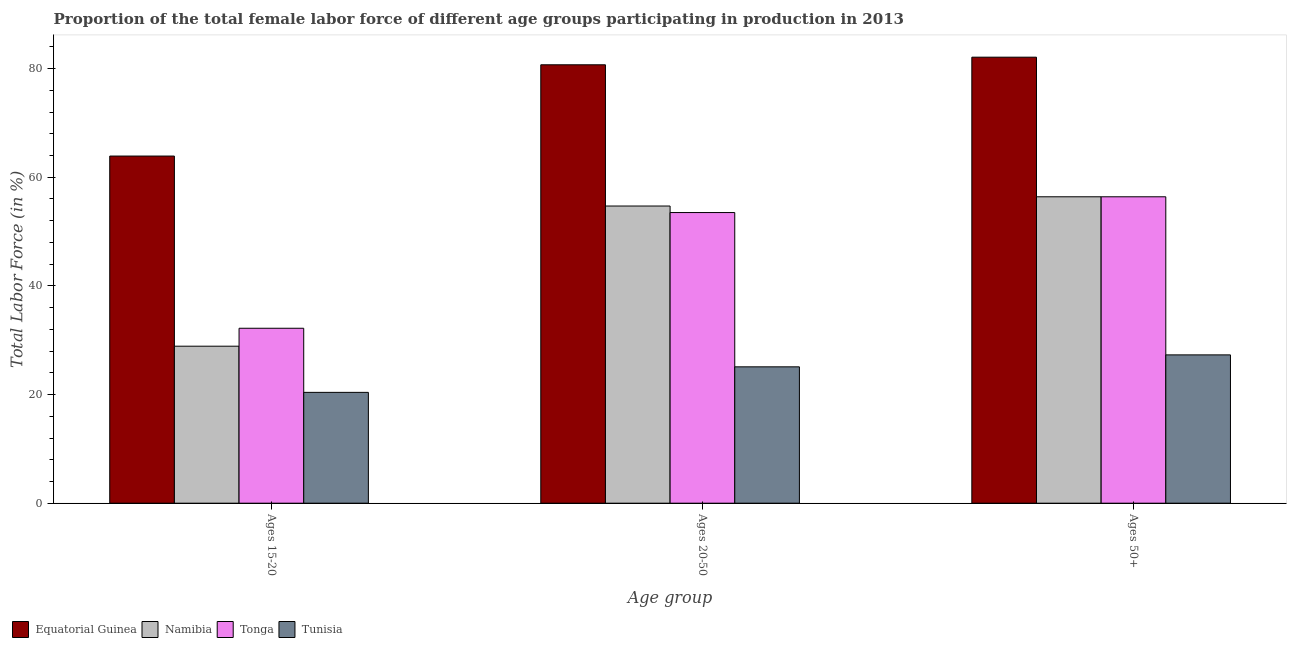How many different coloured bars are there?
Your answer should be very brief. 4. Are the number of bars per tick equal to the number of legend labels?
Make the answer very short. Yes. Are the number of bars on each tick of the X-axis equal?
Provide a succinct answer. Yes. How many bars are there on the 2nd tick from the left?
Provide a short and direct response. 4. How many bars are there on the 2nd tick from the right?
Provide a succinct answer. 4. What is the label of the 2nd group of bars from the left?
Provide a succinct answer. Ages 20-50. What is the percentage of female labor force within the age group 15-20 in Equatorial Guinea?
Give a very brief answer. 63.9. Across all countries, what is the maximum percentage of female labor force within the age group 20-50?
Provide a short and direct response. 80.7. Across all countries, what is the minimum percentage of female labor force above age 50?
Offer a terse response. 27.3. In which country was the percentage of female labor force within the age group 20-50 maximum?
Ensure brevity in your answer.  Equatorial Guinea. In which country was the percentage of female labor force within the age group 15-20 minimum?
Your response must be concise. Tunisia. What is the total percentage of female labor force within the age group 15-20 in the graph?
Your response must be concise. 145.4. What is the difference between the percentage of female labor force within the age group 15-20 in Tonga and that in Tunisia?
Provide a short and direct response. 11.8. What is the difference between the percentage of female labor force within the age group 20-50 in Equatorial Guinea and the percentage of female labor force within the age group 15-20 in Namibia?
Provide a succinct answer. 51.8. What is the average percentage of female labor force above age 50 per country?
Give a very brief answer. 55.55. What is the difference between the percentage of female labor force within the age group 20-50 and percentage of female labor force above age 50 in Namibia?
Provide a short and direct response. -1.7. What is the ratio of the percentage of female labor force above age 50 in Tunisia to that in Tonga?
Your response must be concise. 0.48. What is the difference between the highest and the second highest percentage of female labor force above age 50?
Provide a succinct answer. 25.7. What is the difference between the highest and the lowest percentage of female labor force within the age group 20-50?
Provide a short and direct response. 55.6. In how many countries, is the percentage of female labor force within the age group 20-50 greater than the average percentage of female labor force within the age group 20-50 taken over all countries?
Give a very brief answer. 3. Is the sum of the percentage of female labor force within the age group 20-50 in Tunisia and Equatorial Guinea greater than the maximum percentage of female labor force above age 50 across all countries?
Make the answer very short. Yes. What does the 2nd bar from the left in Ages 50+ represents?
Make the answer very short. Namibia. What does the 3rd bar from the right in Ages 20-50 represents?
Offer a terse response. Namibia. How many countries are there in the graph?
Your answer should be compact. 4. What is the difference between two consecutive major ticks on the Y-axis?
Keep it short and to the point. 20. Where does the legend appear in the graph?
Your answer should be compact. Bottom left. How many legend labels are there?
Provide a succinct answer. 4. What is the title of the graph?
Your response must be concise. Proportion of the total female labor force of different age groups participating in production in 2013. What is the label or title of the X-axis?
Provide a short and direct response. Age group. What is the Total Labor Force (in %) in Equatorial Guinea in Ages 15-20?
Provide a short and direct response. 63.9. What is the Total Labor Force (in %) in Namibia in Ages 15-20?
Offer a very short reply. 28.9. What is the Total Labor Force (in %) of Tonga in Ages 15-20?
Your answer should be compact. 32.2. What is the Total Labor Force (in %) of Tunisia in Ages 15-20?
Ensure brevity in your answer.  20.4. What is the Total Labor Force (in %) in Equatorial Guinea in Ages 20-50?
Give a very brief answer. 80.7. What is the Total Labor Force (in %) of Namibia in Ages 20-50?
Your answer should be compact. 54.7. What is the Total Labor Force (in %) of Tonga in Ages 20-50?
Your answer should be compact. 53.5. What is the Total Labor Force (in %) of Tunisia in Ages 20-50?
Provide a short and direct response. 25.1. What is the Total Labor Force (in %) of Equatorial Guinea in Ages 50+?
Ensure brevity in your answer.  82.1. What is the Total Labor Force (in %) of Namibia in Ages 50+?
Provide a short and direct response. 56.4. What is the Total Labor Force (in %) in Tonga in Ages 50+?
Provide a short and direct response. 56.4. What is the Total Labor Force (in %) of Tunisia in Ages 50+?
Ensure brevity in your answer.  27.3. Across all Age group, what is the maximum Total Labor Force (in %) of Equatorial Guinea?
Provide a short and direct response. 82.1. Across all Age group, what is the maximum Total Labor Force (in %) of Namibia?
Your answer should be compact. 56.4. Across all Age group, what is the maximum Total Labor Force (in %) of Tonga?
Offer a terse response. 56.4. Across all Age group, what is the maximum Total Labor Force (in %) of Tunisia?
Your response must be concise. 27.3. Across all Age group, what is the minimum Total Labor Force (in %) of Equatorial Guinea?
Provide a succinct answer. 63.9. Across all Age group, what is the minimum Total Labor Force (in %) in Namibia?
Your answer should be compact. 28.9. Across all Age group, what is the minimum Total Labor Force (in %) in Tonga?
Offer a terse response. 32.2. Across all Age group, what is the minimum Total Labor Force (in %) of Tunisia?
Give a very brief answer. 20.4. What is the total Total Labor Force (in %) of Equatorial Guinea in the graph?
Make the answer very short. 226.7. What is the total Total Labor Force (in %) of Namibia in the graph?
Provide a short and direct response. 140. What is the total Total Labor Force (in %) of Tonga in the graph?
Your answer should be very brief. 142.1. What is the total Total Labor Force (in %) of Tunisia in the graph?
Your response must be concise. 72.8. What is the difference between the Total Labor Force (in %) in Equatorial Guinea in Ages 15-20 and that in Ages 20-50?
Give a very brief answer. -16.8. What is the difference between the Total Labor Force (in %) in Namibia in Ages 15-20 and that in Ages 20-50?
Your response must be concise. -25.8. What is the difference between the Total Labor Force (in %) in Tonga in Ages 15-20 and that in Ages 20-50?
Give a very brief answer. -21.3. What is the difference between the Total Labor Force (in %) of Tunisia in Ages 15-20 and that in Ages 20-50?
Your answer should be compact. -4.7. What is the difference between the Total Labor Force (in %) in Equatorial Guinea in Ages 15-20 and that in Ages 50+?
Offer a terse response. -18.2. What is the difference between the Total Labor Force (in %) of Namibia in Ages 15-20 and that in Ages 50+?
Keep it short and to the point. -27.5. What is the difference between the Total Labor Force (in %) of Tonga in Ages 15-20 and that in Ages 50+?
Offer a very short reply. -24.2. What is the difference between the Total Labor Force (in %) in Equatorial Guinea in Ages 20-50 and that in Ages 50+?
Ensure brevity in your answer.  -1.4. What is the difference between the Total Labor Force (in %) in Namibia in Ages 20-50 and that in Ages 50+?
Keep it short and to the point. -1.7. What is the difference between the Total Labor Force (in %) in Tonga in Ages 20-50 and that in Ages 50+?
Your response must be concise. -2.9. What is the difference between the Total Labor Force (in %) in Tunisia in Ages 20-50 and that in Ages 50+?
Provide a short and direct response. -2.2. What is the difference between the Total Labor Force (in %) of Equatorial Guinea in Ages 15-20 and the Total Labor Force (in %) of Namibia in Ages 20-50?
Provide a succinct answer. 9.2. What is the difference between the Total Labor Force (in %) of Equatorial Guinea in Ages 15-20 and the Total Labor Force (in %) of Tunisia in Ages 20-50?
Provide a short and direct response. 38.8. What is the difference between the Total Labor Force (in %) of Namibia in Ages 15-20 and the Total Labor Force (in %) of Tonga in Ages 20-50?
Provide a succinct answer. -24.6. What is the difference between the Total Labor Force (in %) in Namibia in Ages 15-20 and the Total Labor Force (in %) in Tunisia in Ages 20-50?
Give a very brief answer. 3.8. What is the difference between the Total Labor Force (in %) of Tonga in Ages 15-20 and the Total Labor Force (in %) of Tunisia in Ages 20-50?
Your answer should be compact. 7.1. What is the difference between the Total Labor Force (in %) in Equatorial Guinea in Ages 15-20 and the Total Labor Force (in %) in Tonga in Ages 50+?
Provide a succinct answer. 7.5. What is the difference between the Total Labor Force (in %) in Equatorial Guinea in Ages 15-20 and the Total Labor Force (in %) in Tunisia in Ages 50+?
Provide a short and direct response. 36.6. What is the difference between the Total Labor Force (in %) of Namibia in Ages 15-20 and the Total Labor Force (in %) of Tonga in Ages 50+?
Your answer should be compact. -27.5. What is the difference between the Total Labor Force (in %) in Equatorial Guinea in Ages 20-50 and the Total Labor Force (in %) in Namibia in Ages 50+?
Offer a terse response. 24.3. What is the difference between the Total Labor Force (in %) of Equatorial Guinea in Ages 20-50 and the Total Labor Force (in %) of Tonga in Ages 50+?
Provide a short and direct response. 24.3. What is the difference between the Total Labor Force (in %) of Equatorial Guinea in Ages 20-50 and the Total Labor Force (in %) of Tunisia in Ages 50+?
Provide a short and direct response. 53.4. What is the difference between the Total Labor Force (in %) of Namibia in Ages 20-50 and the Total Labor Force (in %) of Tonga in Ages 50+?
Give a very brief answer. -1.7. What is the difference between the Total Labor Force (in %) in Namibia in Ages 20-50 and the Total Labor Force (in %) in Tunisia in Ages 50+?
Offer a terse response. 27.4. What is the difference between the Total Labor Force (in %) of Tonga in Ages 20-50 and the Total Labor Force (in %) of Tunisia in Ages 50+?
Your answer should be very brief. 26.2. What is the average Total Labor Force (in %) of Equatorial Guinea per Age group?
Your response must be concise. 75.57. What is the average Total Labor Force (in %) of Namibia per Age group?
Your answer should be compact. 46.67. What is the average Total Labor Force (in %) of Tonga per Age group?
Give a very brief answer. 47.37. What is the average Total Labor Force (in %) of Tunisia per Age group?
Keep it short and to the point. 24.27. What is the difference between the Total Labor Force (in %) of Equatorial Guinea and Total Labor Force (in %) of Tonga in Ages 15-20?
Provide a succinct answer. 31.7. What is the difference between the Total Labor Force (in %) of Equatorial Guinea and Total Labor Force (in %) of Tunisia in Ages 15-20?
Provide a succinct answer. 43.5. What is the difference between the Total Labor Force (in %) of Namibia and Total Labor Force (in %) of Tunisia in Ages 15-20?
Provide a succinct answer. 8.5. What is the difference between the Total Labor Force (in %) in Tonga and Total Labor Force (in %) in Tunisia in Ages 15-20?
Offer a terse response. 11.8. What is the difference between the Total Labor Force (in %) of Equatorial Guinea and Total Labor Force (in %) of Tonga in Ages 20-50?
Your answer should be compact. 27.2. What is the difference between the Total Labor Force (in %) in Equatorial Guinea and Total Labor Force (in %) in Tunisia in Ages 20-50?
Make the answer very short. 55.6. What is the difference between the Total Labor Force (in %) in Namibia and Total Labor Force (in %) in Tonga in Ages 20-50?
Your response must be concise. 1.2. What is the difference between the Total Labor Force (in %) of Namibia and Total Labor Force (in %) of Tunisia in Ages 20-50?
Provide a succinct answer. 29.6. What is the difference between the Total Labor Force (in %) in Tonga and Total Labor Force (in %) in Tunisia in Ages 20-50?
Give a very brief answer. 28.4. What is the difference between the Total Labor Force (in %) of Equatorial Guinea and Total Labor Force (in %) of Namibia in Ages 50+?
Offer a very short reply. 25.7. What is the difference between the Total Labor Force (in %) of Equatorial Guinea and Total Labor Force (in %) of Tonga in Ages 50+?
Give a very brief answer. 25.7. What is the difference between the Total Labor Force (in %) in Equatorial Guinea and Total Labor Force (in %) in Tunisia in Ages 50+?
Offer a very short reply. 54.8. What is the difference between the Total Labor Force (in %) of Namibia and Total Labor Force (in %) of Tunisia in Ages 50+?
Your response must be concise. 29.1. What is the difference between the Total Labor Force (in %) in Tonga and Total Labor Force (in %) in Tunisia in Ages 50+?
Offer a terse response. 29.1. What is the ratio of the Total Labor Force (in %) of Equatorial Guinea in Ages 15-20 to that in Ages 20-50?
Offer a very short reply. 0.79. What is the ratio of the Total Labor Force (in %) of Namibia in Ages 15-20 to that in Ages 20-50?
Keep it short and to the point. 0.53. What is the ratio of the Total Labor Force (in %) in Tonga in Ages 15-20 to that in Ages 20-50?
Your answer should be very brief. 0.6. What is the ratio of the Total Labor Force (in %) in Tunisia in Ages 15-20 to that in Ages 20-50?
Give a very brief answer. 0.81. What is the ratio of the Total Labor Force (in %) in Equatorial Guinea in Ages 15-20 to that in Ages 50+?
Your answer should be very brief. 0.78. What is the ratio of the Total Labor Force (in %) in Namibia in Ages 15-20 to that in Ages 50+?
Give a very brief answer. 0.51. What is the ratio of the Total Labor Force (in %) of Tonga in Ages 15-20 to that in Ages 50+?
Your answer should be very brief. 0.57. What is the ratio of the Total Labor Force (in %) of Tunisia in Ages 15-20 to that in Ages 50+?
Your response must be concise. 0.75. What is the ratio of the Total Labor Force (in %) in Equatorial Guinea in Ages 20-50 to that in Ages 50+?
Give a very brief answer. 0.98. What is the ratio of the Total Labor Force (in %) in Namibia in Ages 20-50 to that in Ages 50+?
Make the answer very short. 0.97. What is the ratio of the Total Labor Force (in %) of Tonga in Ages 20-50 to that in Ages 50+?
Your response must be concise. 0.95. What is the ratio of the Total Labor Force (in %) in Tunisia in Ages 20-50 to that in Ages 50+?
Ensure brevity in your answer.  0.92. What is the difference between the highest and the lowest Total Labor Force (in %) in Equatorial Guinea?
Your answer should be compact. 18.2. What is the difference between the highest and the lowest Total Labor Force (in %) in Namibia?
Make the answer very short. 27.5. What is the difference between the highest and the lowest Total Labor Force (in %) in Tonga?
Ensure brevity in your answer.  24.2. What is the difference between the highest and the lowest Total Labor Force (in %) in Tunisia?
Your answer should be compact. 6.9. 